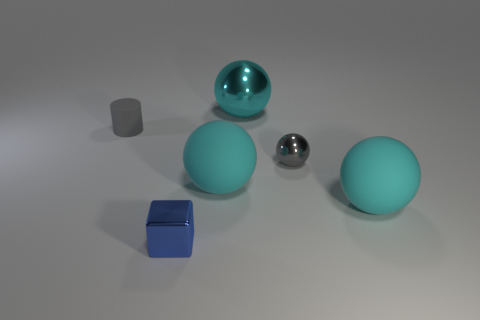Subtract all blue blocks. How many cyan balls are left? 3 Add 4 small brown cubes. How many objects exist? 10 Subtract all blocks. How many objects are left? 5 Subtract 0 yellow blocks. How many objects are left? 6 Subtract all small yellow rubber balls. Subtract all blue blocks. How many objects are left? 5 Add 4 gray rubber cylinders. How many gray rubber cylinders are left? 5 Add 5 big brown shiny cylinders. How many big brown shiny cylinders exist? 5 